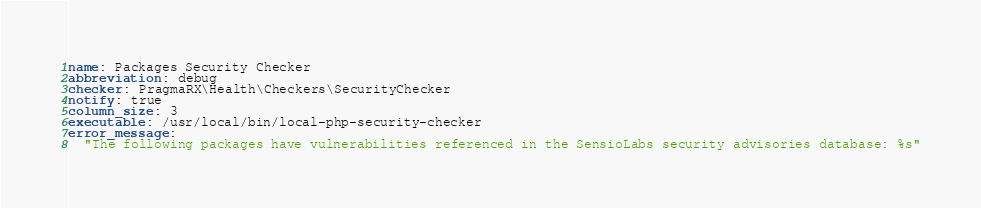<code> <loc_0><loc_0><loc_500><loc_500><_YAML_>name: Packages Security Checker
abbreviation: debug
checker: PragmaRX\Health\Checkers\SecurityChecker
notify: true
column_size: 3
executable: /usr/local/bin/local-php-security-checker
error_message:
  "The following packages have vulnerabilities referenced in the SensioLabs security advisories database: %s"
</code> 